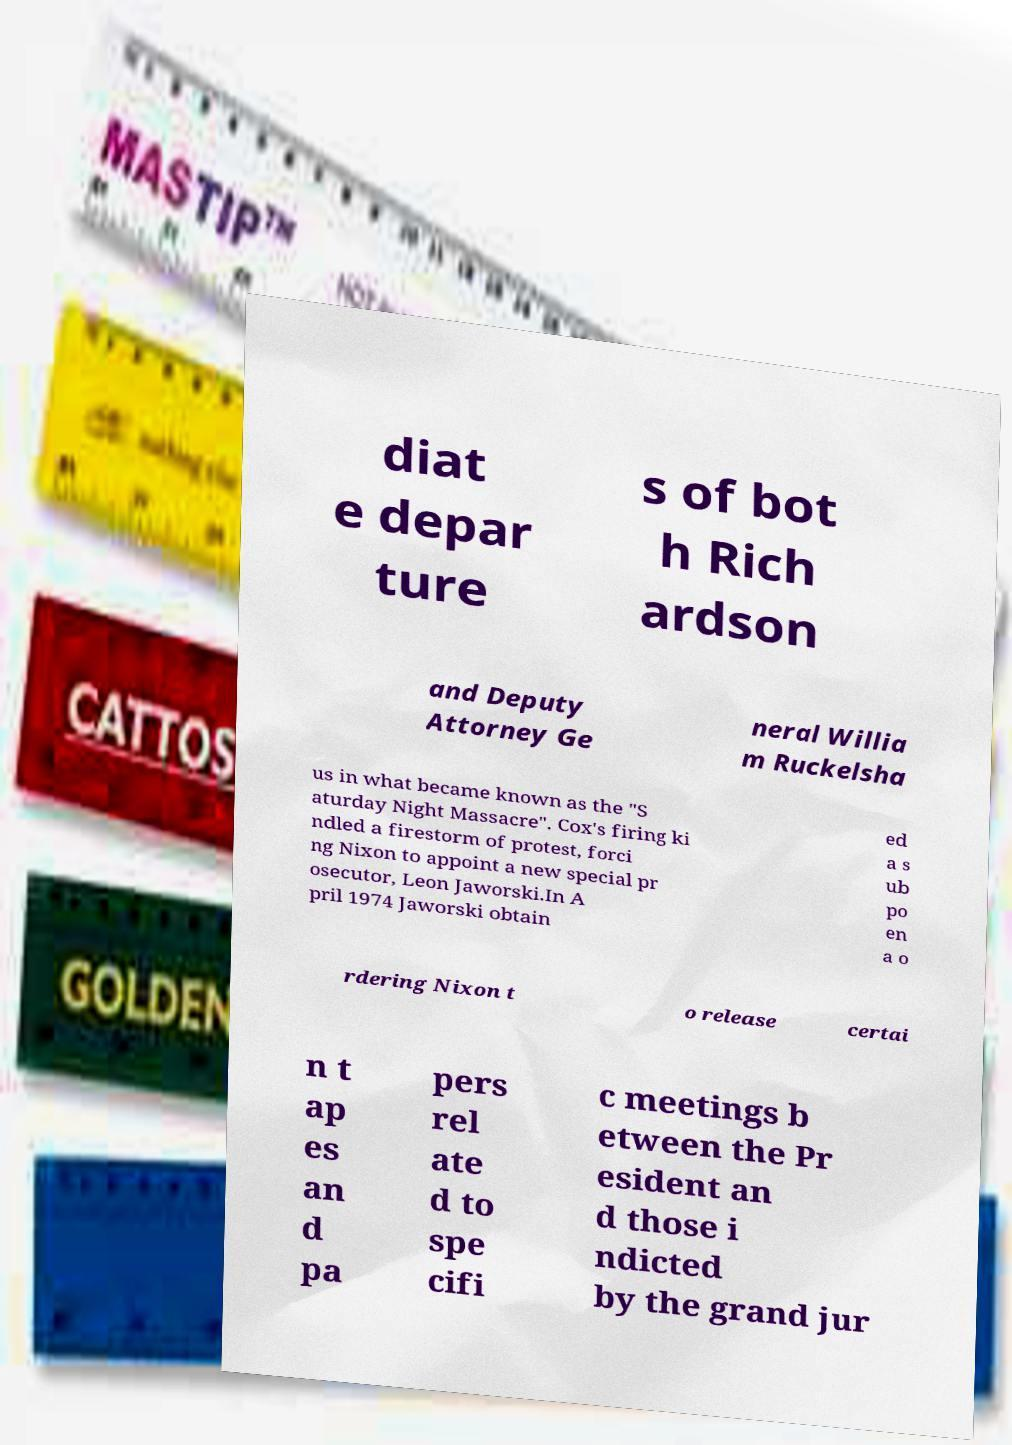For documentation purposes, I need the text within this image transcribed. Could you provide that? diat e depar ture s of bot h Rich ardson and Deputy Attorney Ge neral Willia m Ruckelsha us in what became known as the "S aturday Night Massacre". Cox's firing ki ndled a firestorm of protest, forci ng Nixon to appoint a new special pr osecutor, Leon Jaworski.In A pril 1974 Jaworski obtain ed a s ub po en a o rdering Nixon t o release certai n t ap es an d pa pers rel ate d to spe cifi c meetings b etween the Pr esident an d those i ndicted by the grand jur 